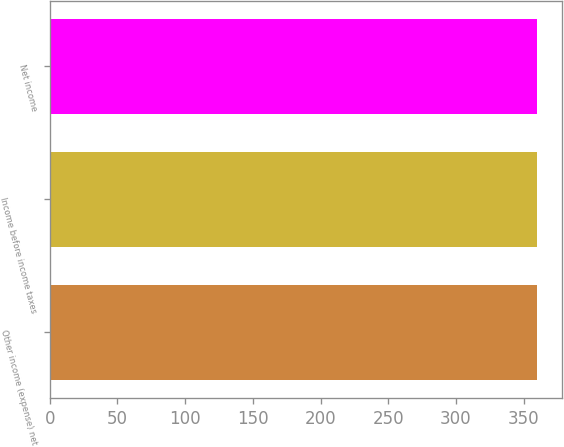<chart> <loc_0><loc_0><loc_500><loc_500><bar_chart><fcel>Other income (expense) net<fcel>Income before income taxes<fcel>Net income<nl><fcel>360<fcel>360.1<fcel>360.2<nl></chart> 